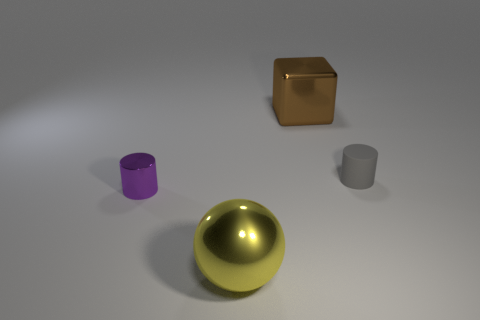Add 1 small rubber cylinders. How many objects exist? 5 Subtract all spheres. How many objects are left? 3 Add 4 big shiny things. How many big shiny things exist? 6 Subtract 0 purple spheres. How many objects are left? 4 Subtract all big yellow metal spheres. Subtract all shiny cylinders. How many objects are left? 2 Add 2 large shiny balls. How many large shiny balls are left? 3 